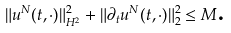Convert formula to latex. <formula><loc_0><loc_0><loc_500><loc_500>\| u ^ { N } ( t , \cdot ) \| _ { H ^ { 2 } } ^ { 2 } + \| \partial _ { t } u ^ { N } ( t , \cdot ) \| _ { 2 } ^ { 2 } \leq M \text {.}</formula> 